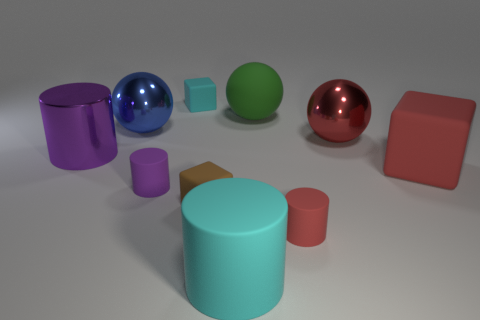There is a big rubber block; does it have the same color as the shiny ball to the right of the big green ball?
Your answer should be very brief. Yes. What color is the large cylinder behind the large red matte object right of the small brown cube?
Make the answer very short. Purple. Is the number of tiny purple cylinders behind the green sphere the same as the number of large cyan metal things?
Offer a very short reply. Yes. Is there a matte cube of the same size as the blue object?
Your answer should be compact. Yes. Is the size of the green object the same as the red rubber object behind the red cylinder?
Your response must be concise. Yes. Are there an equal number of small red cylinders that are on the right side of the large blue shiny ball and big cylinders that are to the left of the small cyan object?
Provide a succinct answer. Yes. There is a small object that is the same color as the shiny cylinder; what is its shape?
Provide a short and direct response. Cylinder. There is a red object behind the large purple metal cylinder; what is its material?
Give a very brief answer. Metal. Do the red metallic object and the green ball have the same size?
Give a very brief answer. Yes. Is the number of tiny cyan matte things that are behind the cyan rubber cylinder greater than the number of big gray metallic cylinders?
Your response must be concise. Yes. 